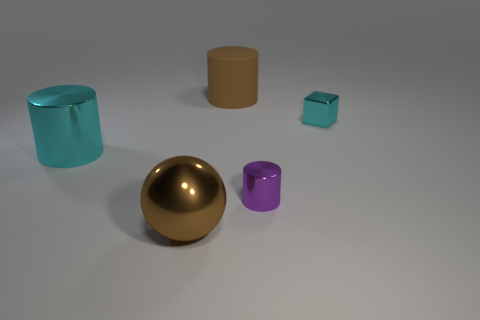Is the size of the sphere the same as the cyan cube?
Offer a very short reply. No. What is the large brown thing that is behind the metal cylinder in front of the cyan metal cylinder made of?
Provide a short and direct response. Rubber. Do the cyan shiny thing on the right side of the rubber object and the large brown object behind the large metal ball have the same shape?
Keep it short and to the point. No. Are there an equal number of large metallic spheres that are behind the block and small yellow shiny cylinders?
Your answer should be very brief. Yes. Are there any small metal cubes that are right of the big object that is on the right side of the sphere?
Provide a succinct answer. Yes. Is there anything else that is the same color as the metal ball?
Keep it short and to the point. Yes. Does the brown thing that is behind the brown sphere have the same material as the cyan cube?
Your answer should be compact. No. Are there an equal number of purple metal things left of the tiny purple metallic thing and tiny cyan shiny objects that are in front of the big brown rubber cylinder?
Your response must be concise. No. How big is the metallic object behind the large cylinder in front of the big brown cylinder?
Keep it short and to the point. Small. What material is the cylinder that is in front of the large brown rubber cylinder and right of the big metallic ball?
Provide a succinct answer. Metal. 